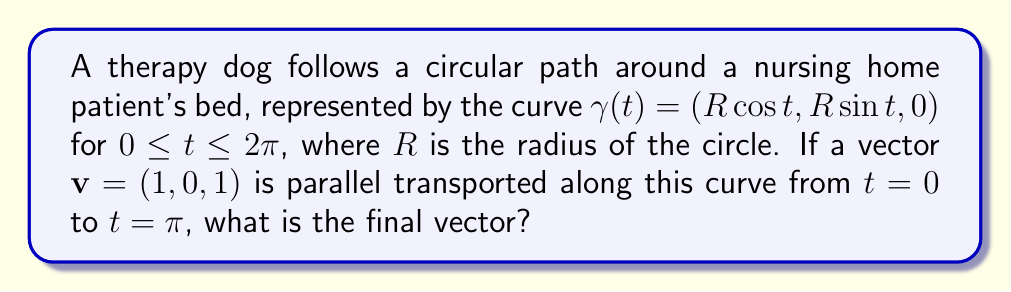Provide a solution to this math problem. Let's approach this step-by-step:

1) For a curve on a surface, the parallel transport of a vector $\mathbf{v}$ is given by the equation:

   $$\frac{D\mathbf{v}}{dt} = 0$$

   where $\frac{D}{dt}$ is the covariant derivative.

2) For a plane curve, the parallel transport keeps the angle between the vector and the tangent vector constant.

3) The tangent vector to the curve at any point is:

   $$\mathbf{T}(t) = (-R\sin t, R\cos t, 0)$$

4) At $t = 0$, the tangent vector is $(0, R, 0)$, and at $t = \pi$, it's $(0, -R, 0)$.

5) The initial vector $\mathbf{v} = (1, 0, 1)$ makes an angle $\theta$ with the initial tangent vector, where:

   $$\cos \theta = \frac{\mathbf{v} \cdot \mathbf{T}(0)}{|\mathbf{v}||\mathbf{T}(0)|} = 0$$

6) This means $\theta = \frac{\pi}{2}$, i.e., the vector is perpendicular to the tangent.

7) To maintain this perpendicularity at $t = \pi$, the vector must rotate 180° in the xy-plane.

8) The z-component remains unchanged as the curve is in the xy-plane.

9) Therefore, the final vector after parallel transport is $(-1, 0, 1)$.
Answer: $(-1, 0, 1)$ 